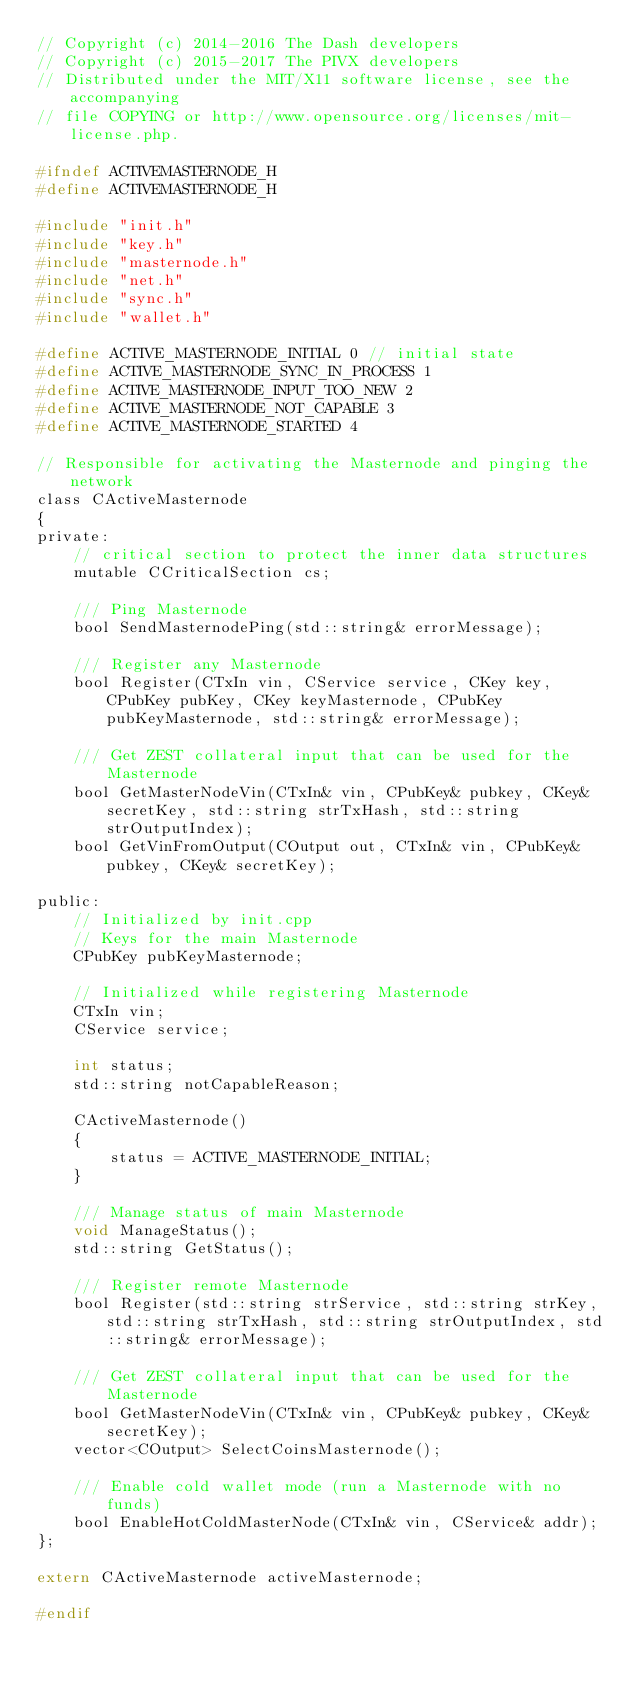<code> <loc_0><loc_0><loc_500><loc_500><_C_>// Copyright (c) 2014-2016 The Dash developers
// Copyright (c) 2015-2017 The PIVX developers
// Distributed under the MIT/X11 software license, see the accompanying
// file COPYING or http://www.opensource.org/licenses/mit-license.php.

#ifndef ACTIVEMASTERNODE_H
#define ACTIVEMASTERNODE_H

#include "init.h"
#include "key.h"
#include "masternode.h"
#include "net.h"
#include "sync.h"
#include "wallet.h"

#define ACTIVE_MASTERNODE_INITIAL 0 // initial state
#define ACTIVE_MASTERNODE_SYNC_IN_PROCESS 1
#define ACTIVE_MASTERNODE_INPUT_TOO_NEW 2
#define ACTIVE_MASTERNODE_NOT_CAPABLE 3
#define ACTIVE_MASTERNODE_STARTED 4

// Responsible for activating the Masternode and pinging the network
class CActiveMasternode
{
private:
    // critical section to protect the inner data structures
    mutable CCriticalSection cs;

    /// Ping Masternode
    bool SendMasternodePing(std::string& errorMessage);

    /// Register any Masternode
    bool Register(CTxIn vin, CService service, CKey key, CPubKey pubKey, CKey keyMasternode, CPubKey pubKeyMasternode, std::string& errorMessage);

    /// Get ZEST collateral input that can be used for the Masternode
    bool GetMasterNodeVin(CTxIn& vin, CPubKey& pubkey, CKey& secretKey, std::string strTxHash, std::string strOutputIndex);
    bool GetVinFromOutput(COutput out, CTxIn& vin, CPubKey& pubkey, CKey& secretKey);

public:
    // Initialized by init.cpp
    // Keys for the main Masternode
    CPubKey pubKeyMasternode;

    // Initialized while registering Masternode
    CTxIn vin;
    CService service;

    int status;
    std::string notCapableReason;

    CActiveMasternode()
    {
        status = ACTIVE_MASTERNODE_INITIAL;
    }

    /// Manage status of main Masternode
    void ManageStatus();
    std::string GetStatus();

    /// Register remote Masternode
    bool Register(std::string strService, std::string strKey, std::string strTxHash, std::string strOutputIndex, std::string& errorMessage);

    /// Get ZEST collateral input that can be used for the Masternode
    bool GetMasterNodeVin(CTxIn& vin, CPubKey& pubkey, CKey& secretKey);
    vector<COutput> SelectCoinsMasternode();

    /// Enable cold wallet mode (run a Masternode with no funds)
    bool EnableHotColdMasterNode(CTxIn& vin, CService& addr);
};

extern CActiveMasternode activeMasternode;

#endif
</code> 